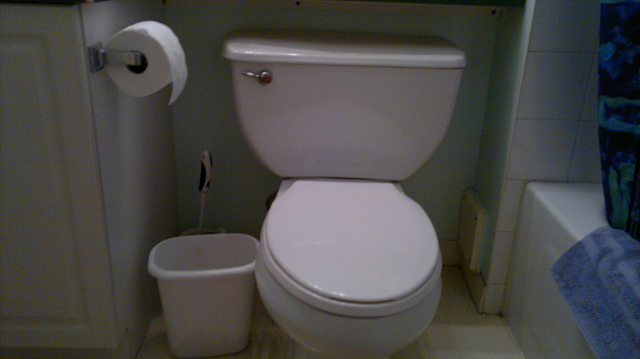<image>What type of cat is this? There is no cat in the image. What type of cat is this? There is no cat in the image. 